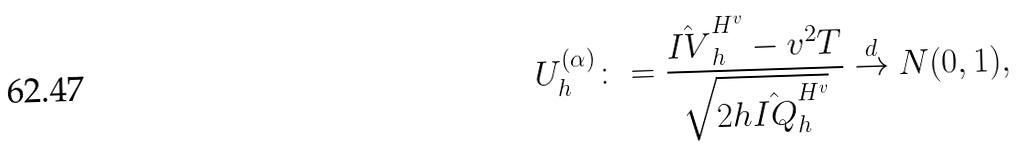<formula> <loc_0><loc_0><loc_500><loc_500>U ^ { ( \alpha ) } _ { h } \colon = \frac { \hat { I V } _ { h } ^ { H ^ { v } } - v ^ { 2 } T } { \sqrt { 2 h \hat { I Q } _ { h } ^ { H ^ { v } } } } \stackrel { d } \rightarrow { N } ( 0 , 1 ) ,</formula> 